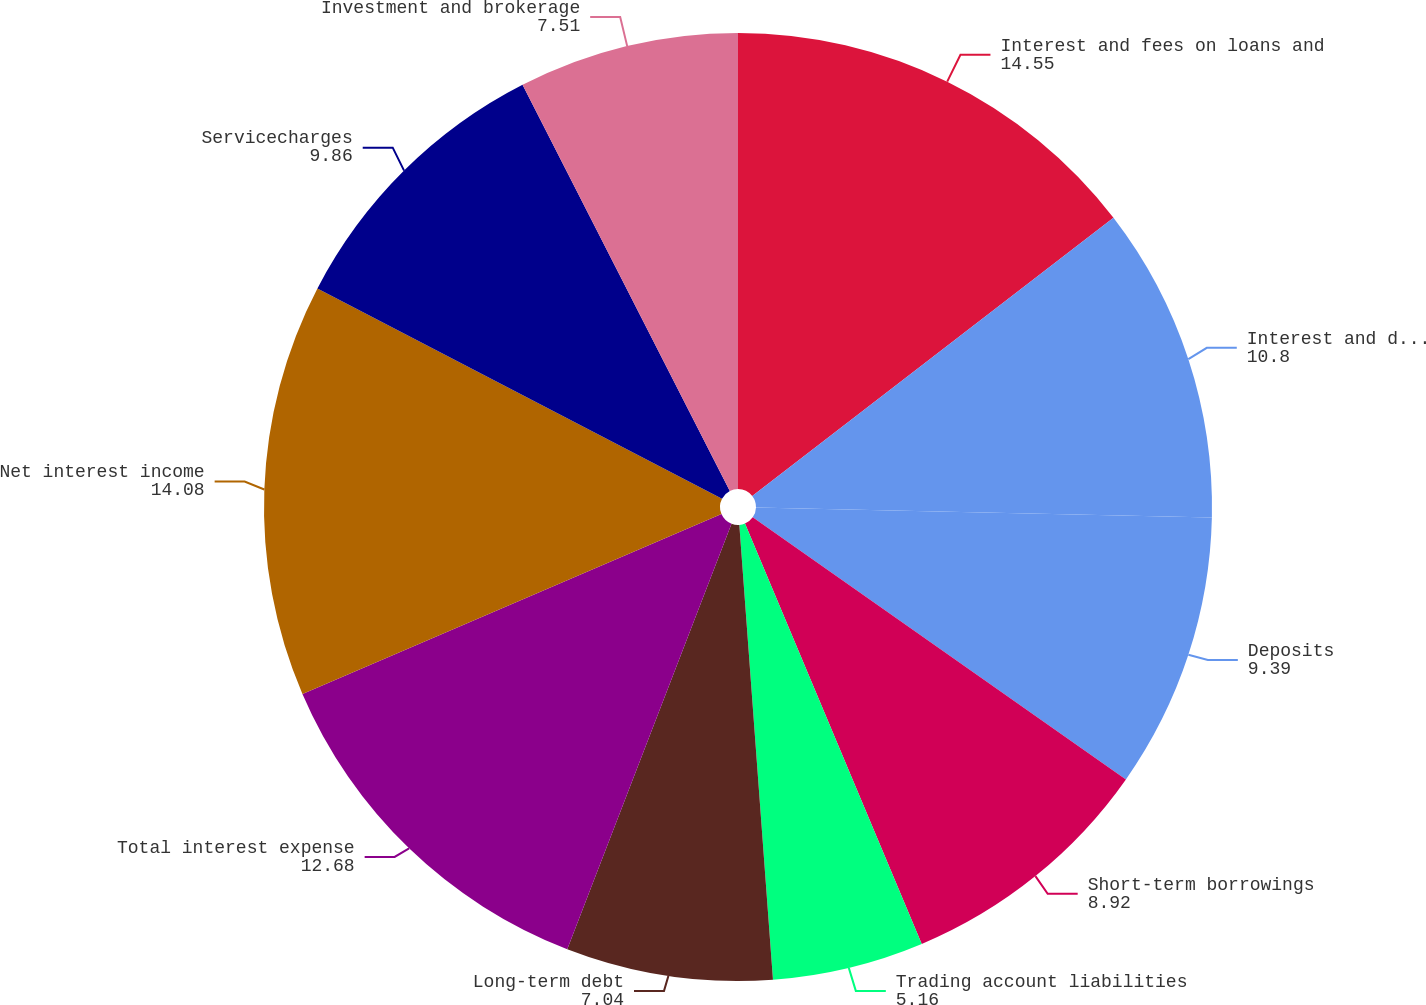Convert chart. <chart><loc_0><loc_0><loc_500><loc_500><pie_chart><fcel>Interest and fees on loans and<fcel>Interest and dividends on<fcel>Deposits<fcel>Short-term borrowings<fcel>Trading account liabilities<fcel>Long-term debt<fcel>Total interest expense<fcel>Net interest income<fcel>Servicecharges<fcel>Investment and brokerage<nl><fcel>14.55%<fcel>10.8%<fcel>9.39%<fcel>8.92%<fcel>5.16%<fcel>7.04%<fcel>12.68%<fcel>14.08%<fcel>9.86%<fcel>7.51%<nl></chart> 